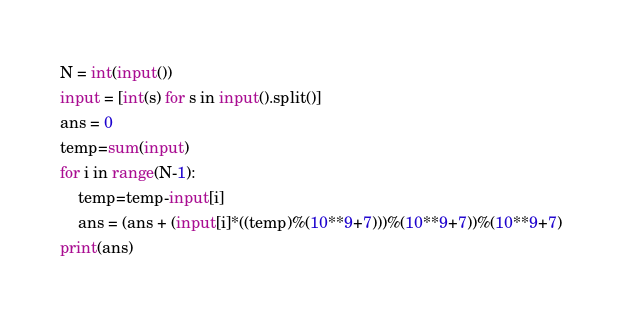<code> <loc_0><loc_0><loc_500><loc_500><_Python_>N = int(input())
input = [int(s) for s in input().split()]
ans = 0
temp=sum(input)
for i in range(N-1):
    temp=temp-input[i]
    ans = (ans + (input[i]*((temp)%(10**9+7)))%(10**9+7))%(10**9+7)
print(ans)</code> 